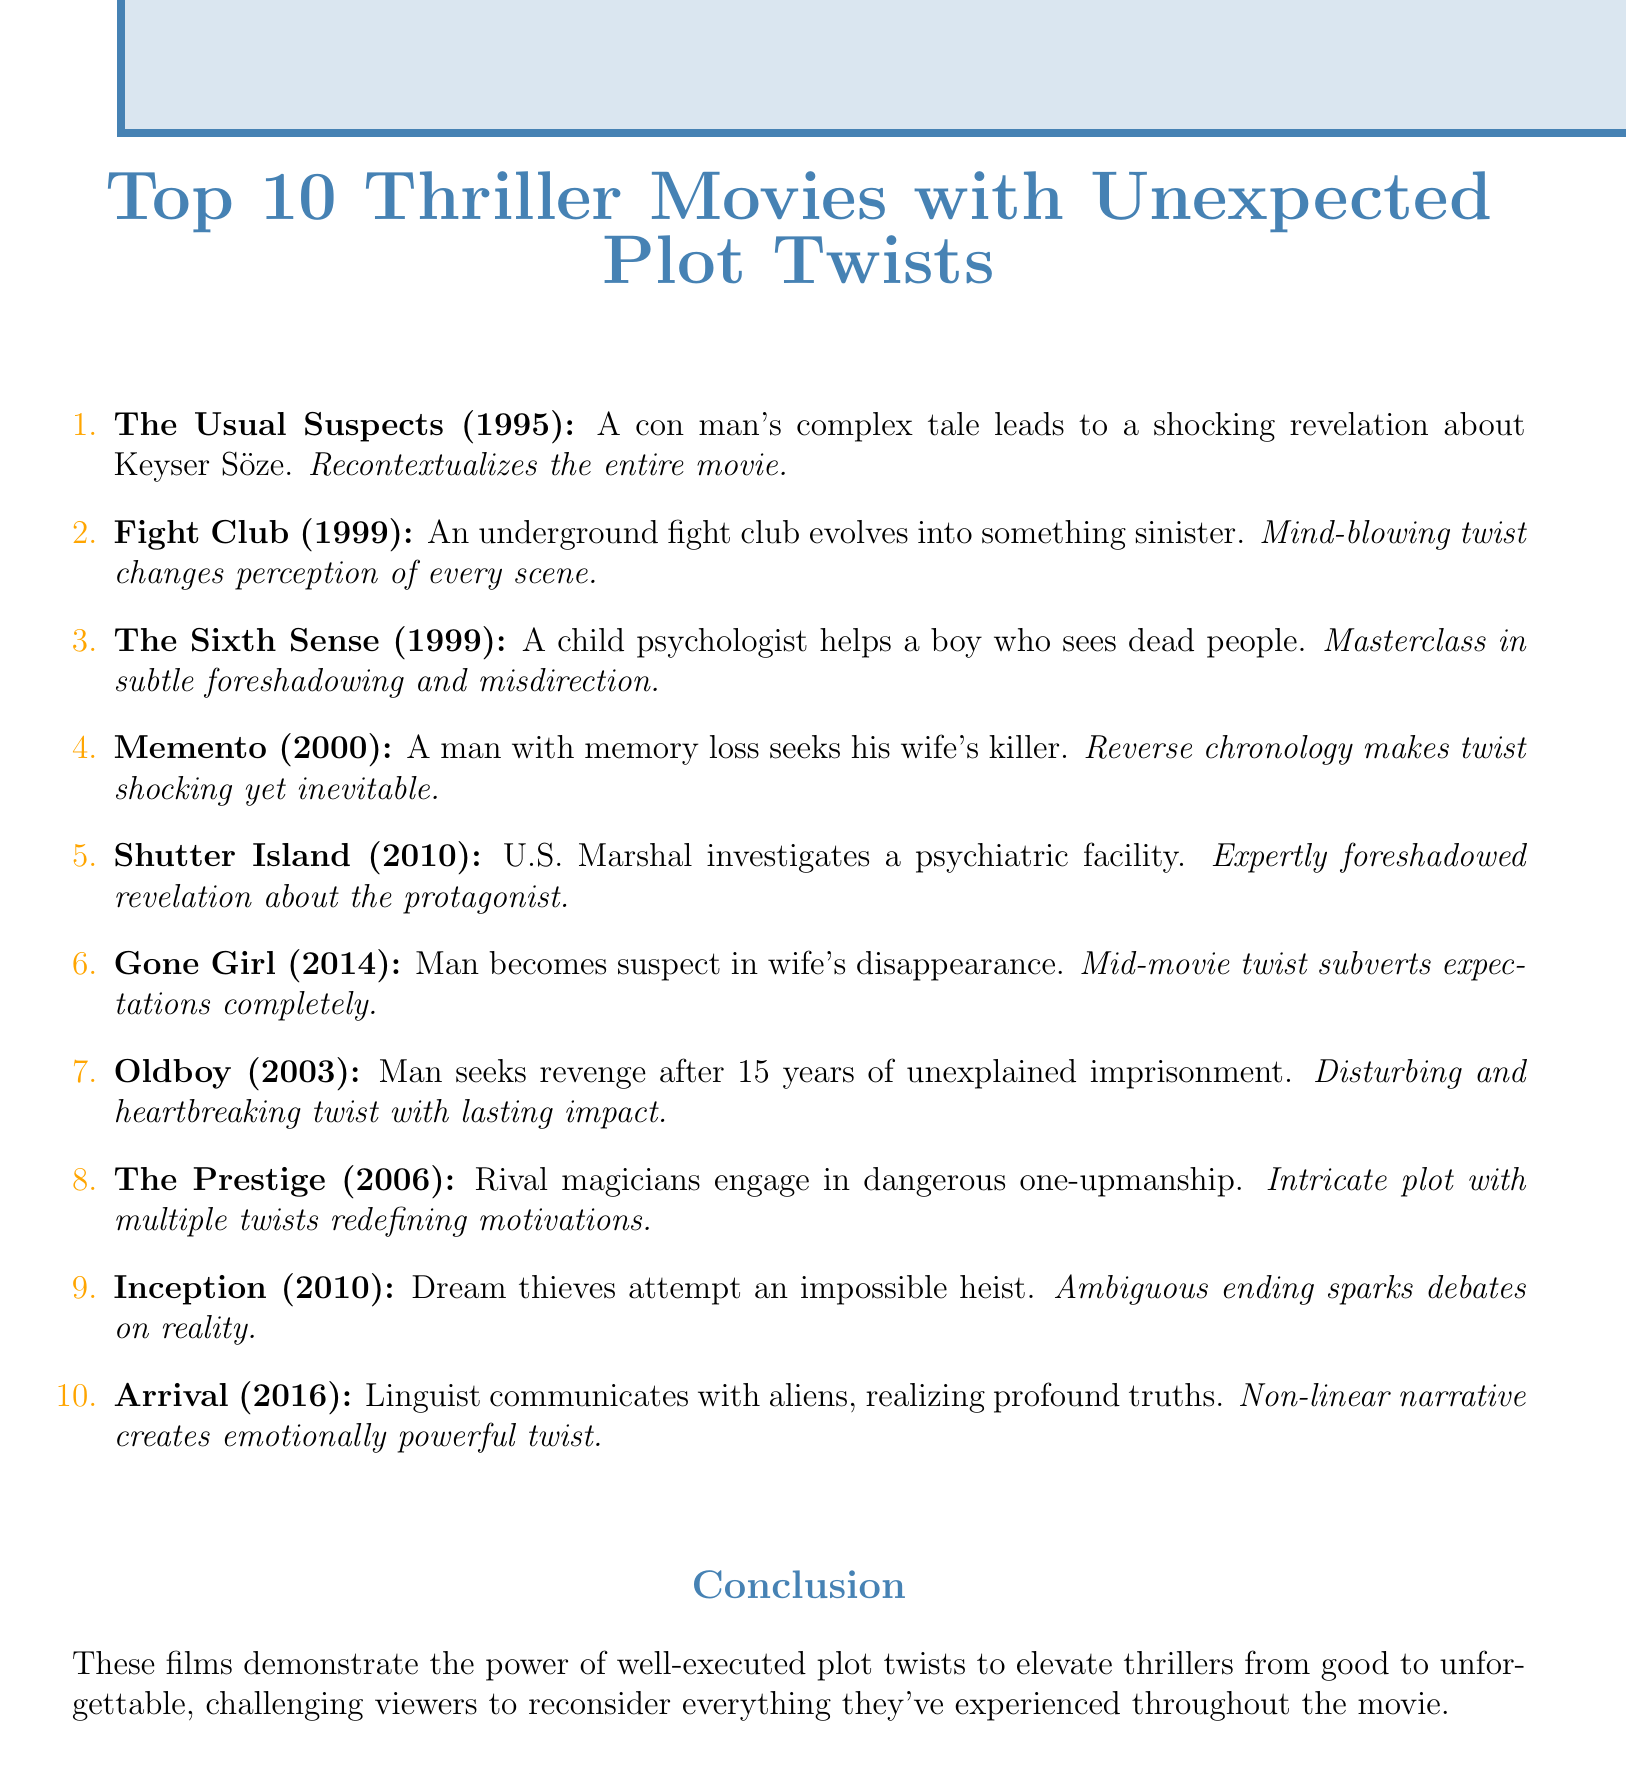What is the release year of "The Usual Suspects"? The document states that "The Usual Suspects" was released in 1995.
Answer: 1995 Which movie features a boy who claims to see dead people? The summary for "The Sixth Sense" mentions a boy who sees dead people.
Answer: The Sixth Sense How many movies are listed in the document? The document lists a total of 10 thriller movies.
Answer: 10 What significant twist occurs in "Fight Club"? The personal thought reveals that the narrator and Tyler Durden are the same person.
Answer: Same person Which film reveals that the protagonist is actually a patient? "Shutter Island" has the twist that the protagonist is a patient.
Answer: Shutter Island What does the twist in "Gone Girl" do to the narrative? The personal thought indicates that the mid-movie twist subverts expectations.
Answer: Subverts expectations What is the theme of "Arrival"? The summary mentions a linguist communicating with aliens, realizing profound truths.
Answer: Communicating with aliens Which movie is described as a "masterclass in subtle foreshadowing"? The summary for "The Sixth Sense" describes it as a masterclass in foreshadowing.
Answer: The Sixth Sense What does the conclusion say about plot twists? The conclusion emphasizes how plot twists elevate thrillers from good to unforgettable.
Answer: Elevate thrillers from good to unforgettable 